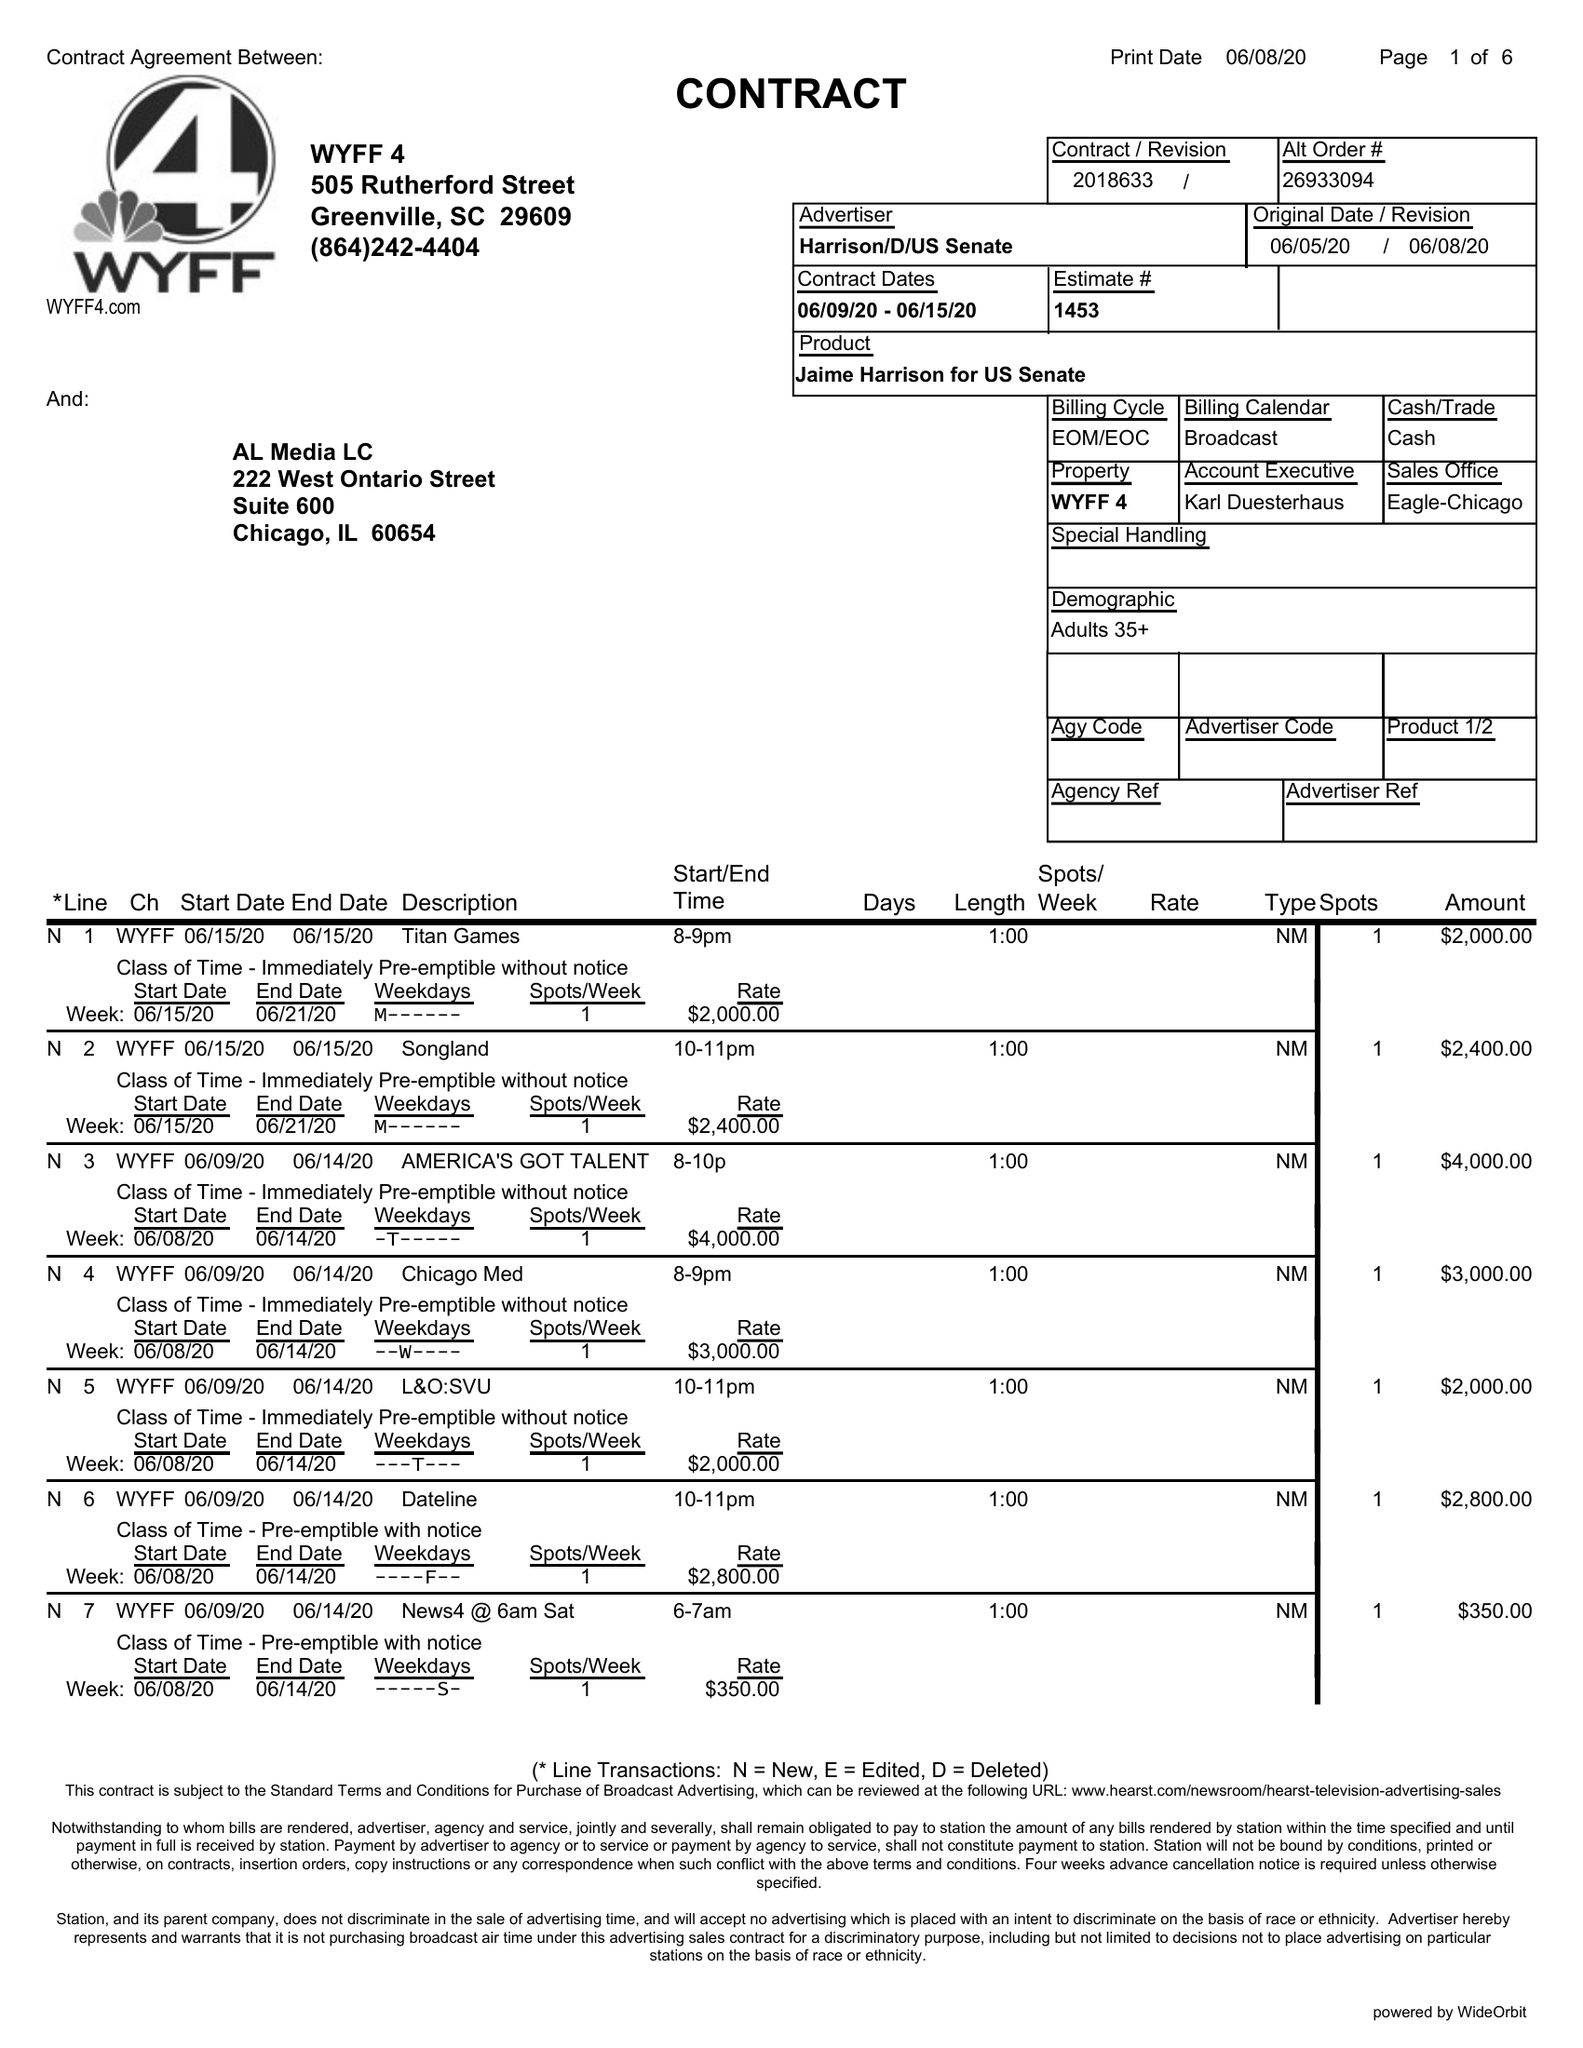What is the value for the contract_num?
Answer the question using a single word or phrase. 2018633 